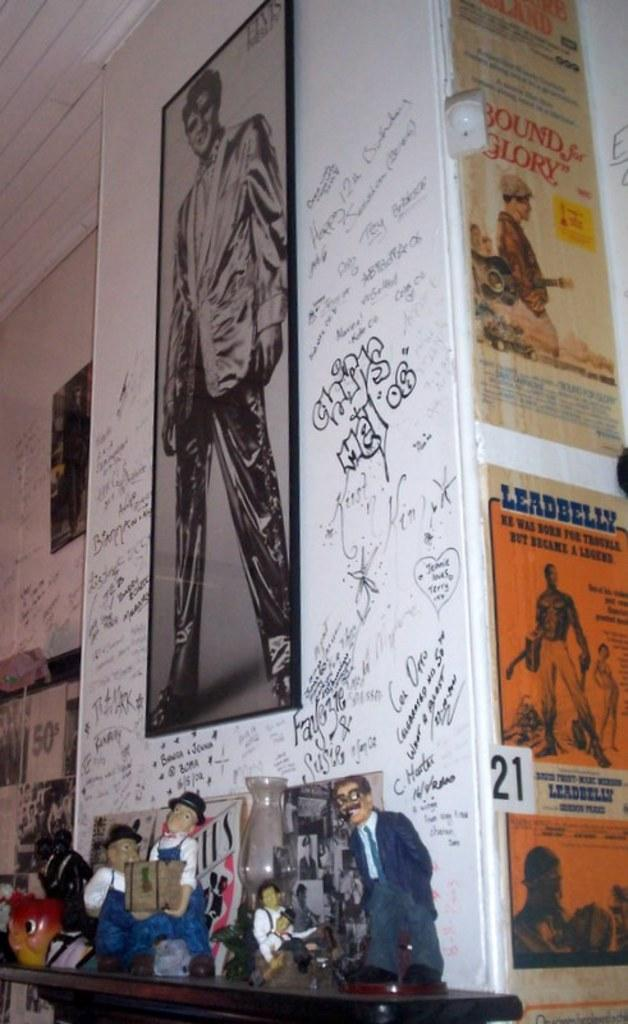<image>
Share a concise interpretation of the image provided. One of the posters on the wall is titled Leadbelly 